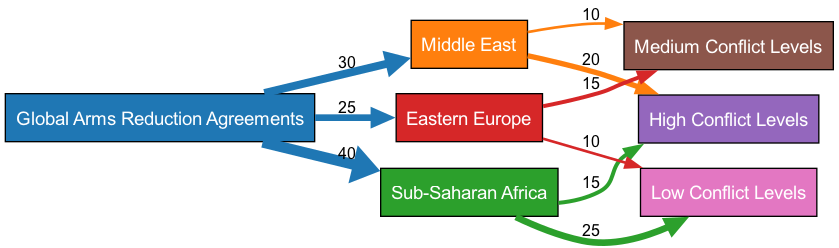What is the total number of nodes in the diagram? The diagram contains a total of 7 nodes: 1 for global arms reduction initiatives, 3 for different regions, and 3 for varying conflict levels.
Answer: 7 What is the value of the flow from arms reduction initiatives to Sub-Saharan Africa? The flow from arms reduction initiatives to Sub-Saharan Africa is represented by a value of 40, indicating a significant linkage.
Answer: 40 Which region has the highest conflict level indicated on the diagram? The Middle East has the highest conflict level with a flow value of 20 going to high conflict levels.
Answer: Middle East What change occurs to the conflict level in Sub-Saharan Africa due to arms reduction initiatives? Due to arms reduction initiatives, Sub-Saharan Africa sees a decrease in high conflict levels (15) and an increase in low conflict levels (25), indicating improved stability.
Answer: Low Conflict Levels How many nodes represent medium conflict levels in the diagram? The diagram shows 2 nodes representing medium conflict levels, specifically for the Middle East and Eastern Europe.
Answer: 2 What is the total value of flows from Eastern Europe to medium and low conflict levels? The total value of flows from Eastern Europe to medium and low conflict levels combines 15 for medium and 10 for low, summing to 25.
Answer: 25 What is the relationship between arms reduction initiatives and conflict levels in the Middle East? Arms reduction initiatives flow to the Middle East, which correlates to 20 to high conflict levels and 10 to medium conflict levels, indicating mixed outcomes in conflict.
Answer: High Conflict Levels What percentage of arms reduction initiatives flow to low conflict levels in Sub-Saharan Africa? To find the percentage, note that 25 flows to low conflict and the total flow to Sub-Saharan Africa is 40, which is 62.5%.
Answer: 62.5% What is the total incoming flow to low conflict levels from all regions? Adding flows from Sub-Saharan Africa (25) and Eastern Europe (10), the total incoming flow to low conflict levels is 35.
Answer: 35 